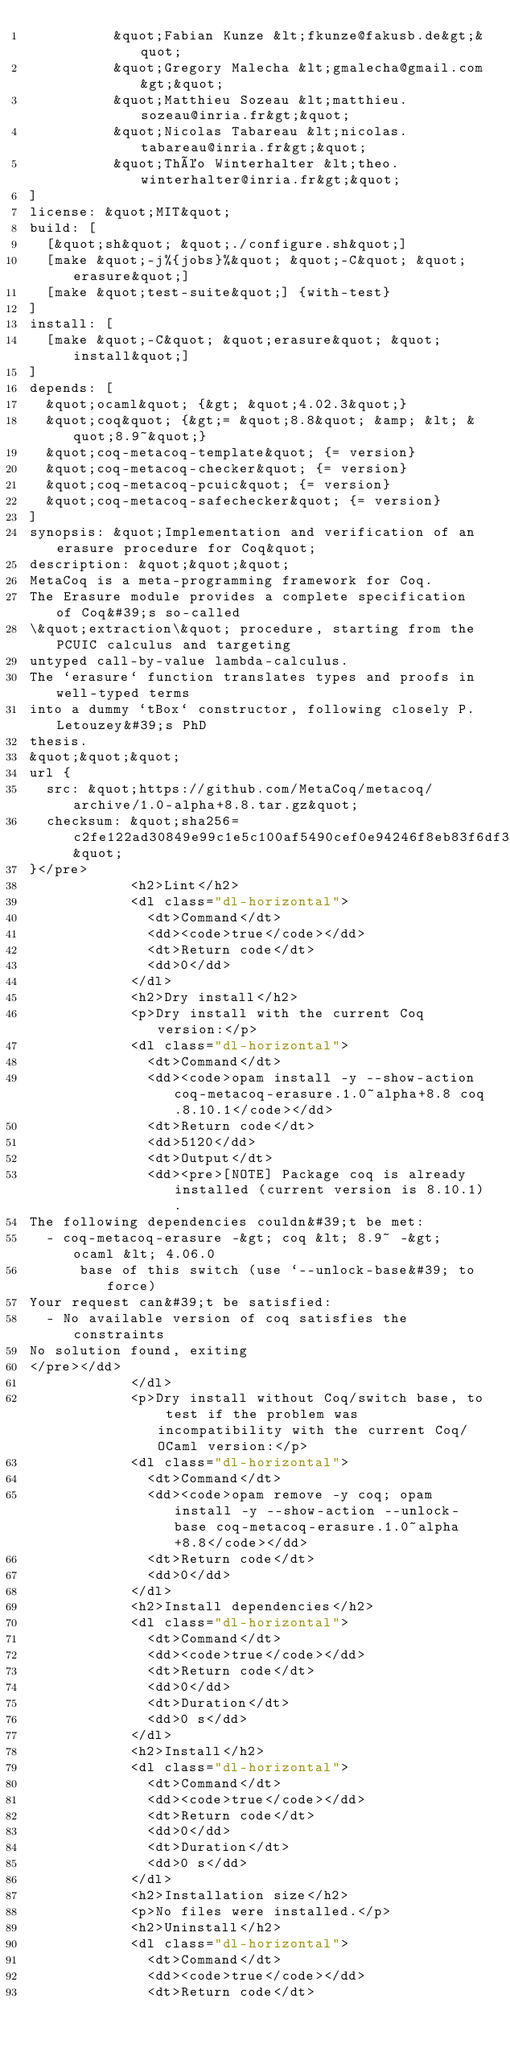Convert code to text. <code><loc_0><loc_0><loc_500><loc_500><_HTML_>          &quot;Fabian Kunze &lt;fkunze@fakusb.de&gt;&quot;
          &quot;Gregory Malecha &lt;gmalecha@gmail.com&gt;&quot;
          &quot;Matthieu Sozeau &lt;matthieu.sozeau@inria.fr&gt;&quot;
          &quot;Nicolas Tabareau &lt;nicolas.tabareau@inria.fr&gt;&quot;
          &quot;Théo Winterhalter &lt;theo.winterhalter@inria.fr&gt;&quot;
]
license: &quot;MIT&quot;
build: [
  [&quot;sh&quot; &quot;./configure.sh&quot;]
  [make &quot;-j%{jobs}%&quot; &quot;-C&quot; &quot;erasure&quot;]
  [make &quot;test-suite&quot;] {with-test}
]
install: [
  [make &quot;-C&quot; &quot;erasure&quot; &quot;install&quot;]
]
depends: [
  &quot;ocaml&quot; {&gt; &quot;4.02.3&quot;}
  &quot;coq&quot; {&gt;= &quot;8.8&quot; &amp; &lt; &quot;8.9~&quot;}
  &quot;coq-metacoq-template&quot; {= version}
  &quot;coq-metacoq-checker&quot; {= version}
  &quot;coq-metacoq-pcuic&quot; {= version}
  &quot;coq-metacoq-safechecker&quot; {= version}
]
synopsis: &quot;Implementation and verification of an erasure procedure for Coq&quot;
description: &quot;&quot;&quot;
MetaCoq is a meta-programming framework for Coq.
The Erasure module provides a complete specification of Coq&#39;s so-called
\&quot;extraction\&quot; procedure, starting from the PCUIC calculus and targeting
untyped call-by-value lambda-calculus.
The `erasure` function translates types and proofs in well-typed terms
into a dummy `tBox` constructor, following closely P. Letouzey&#39;s PhD
thesis.
&quot;&quot;&quot;
url {
  src: &quot;https://github.com/MetaCoq/metacoq/archive/1.0-alpha+8.8.tar.gz&quot;
  checksum: &quot;sha256=c2fe122ad30849e99c1e5c100af5490cef0e94246f8eb83f6df3f2ccf9edfc04&quot;
}</pre>
            <h2>Lint</h2>
            <dl class="dl-horizontal">
              <dt>Command</dt>
              <dd><code>true</code></dd>
              <dt>Return code</dt>
              <dd>0</dd>
            </dl>
            <h2>Dry install</h2>
            <p>Dry install with the current Coq version:</p>
            <dl class="dl-horizontal">
              <dt>Command</dt>
              <dd><code>opam install -y --show-action coq-metacoq-erasure.1.0~alpha+8.8 coq.8.10.1</code></dd>
              <dt>Return code</dt>
              <dd>5120</dd>
              <dt>Output</dt>
              <dd><pre>[NOTE] Package coq is already installed (current version is 8.10.1).
The following dependencies couldn&#39;t be met:
  - coq-metacoq-erasure -&gt; coq &lt; 8.9~ -&gt; ocaml &lt; 4.06.0
      base of this switch (use `--unlock-base&#39; to force)
Your request can&#39;t be satisfied:
  - No available version of coq satisfies the constraints
No solution found, exiting
</pre></dd>
            </dl>
            <p>Dry install without Coq/switch base, to test if the problem was incompatibility with the current Coq/OCaml version:</p>
            <dl class="dl-horizontal">
              <dt>Command</dt>
              <dd><code>opam remove -y coq; opam install -y --show-action --unlock-base coq-metacoq-erasure.1.0~alpha+8.8</code></dd>
              <dt>Return code</dt>
              <dd>0</dd>
            </dl>
            <h2>Install dependencies</h2>
            <dl class="dl-horizontal">
              <dt>Command</dt>
              <dd><code>true</code></dd>
              <dt>Return code</dt>
              <dd>0</dd>
              <dt>Duration</dt>
              <dd>0 s</dd>
            </dl>
            <h2>Install</h2>
            <dl class="dl-horizontal">
              <dt>Command</dt>
              <dd><code>true</code></dd>
              <dt>Return code</dt>
              <dd>0</dd>
              <dt>Duration</dt>
              <dd>0 s</dd>
            </dl>
            <h2>Installation size</h2>
            <p>No files were installed.</p>
            <h2>Uninstall</h2>
            <dl class="dl-horizontal">
              <dt>Command</dt>
              <dd><code>true</code></dd>
              <dt>Return code</dt></code> 